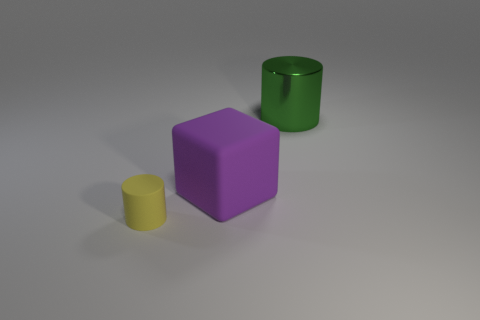Add 1 large purple things. How many objects exist? 4 Subtract all blocks. How many objects are left? 2 Subtract all yellow cylinders. Subtract all big brown metallic cylinders. How many objects are left? 2 Add 2 big green metal objects. How many big green metal objects are left? 3 Add 2 cubes. How many cubes exist? 3 Subtract 0 brown cylinders. How many objects are left? 3 